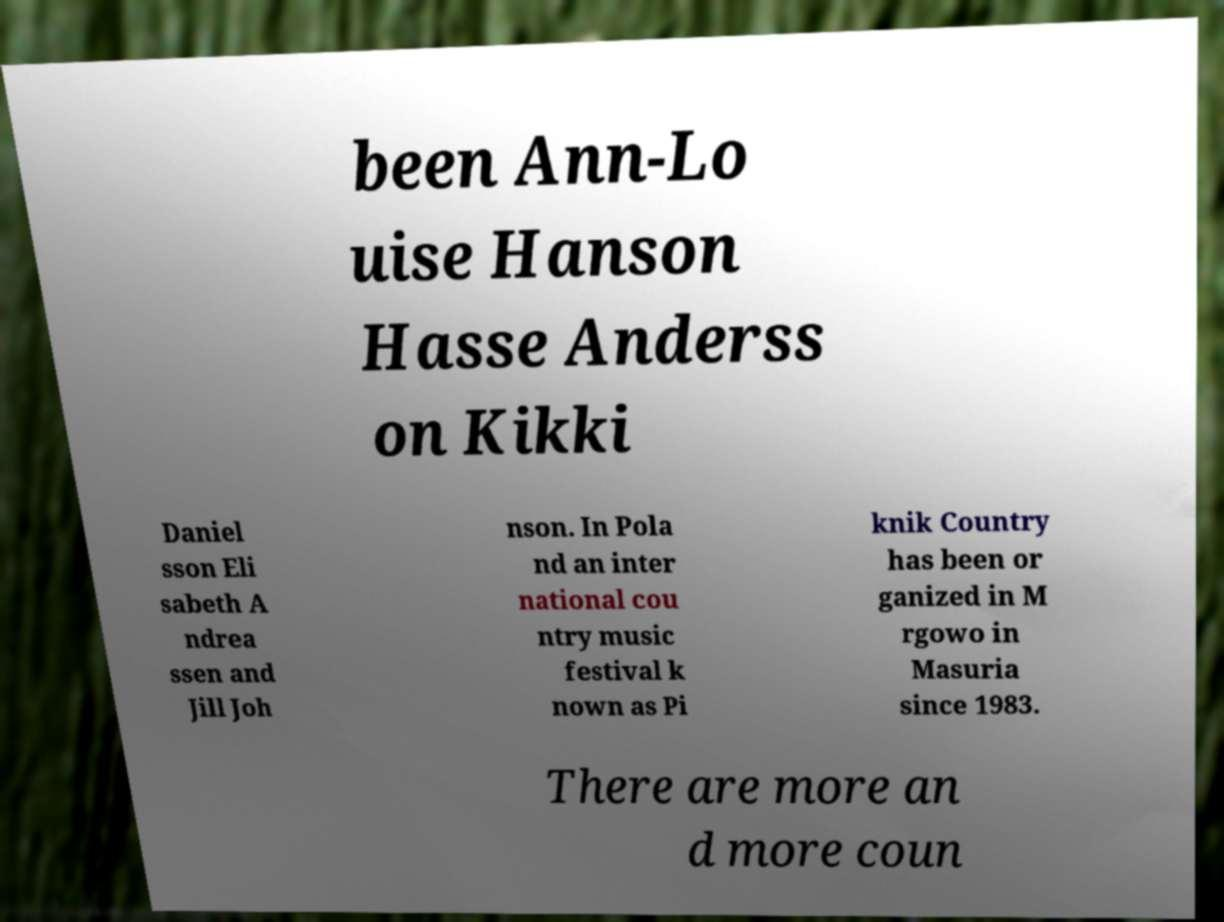Can you read and provide the text displayed in the image?This photo seems to have some interesting text. Can you extract and type it out for me? been Ann-Lo uise Hanson Hasse Anderss on Kikki Daniel sson Eli sabeth A ndrea ssen and Jill Joh nson. In Pola nd an inter national cou ntry music festival k nown as Pi knik Country has been or ganized in M rgowo in Masuria since 1983. There are more an d more coun 